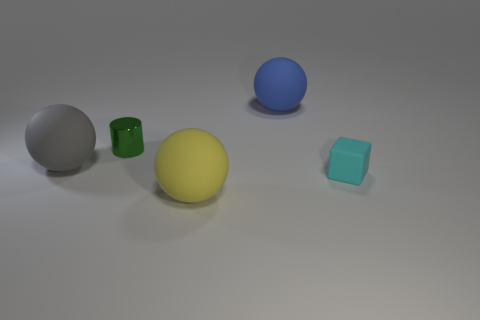Add 1 big yellow matte things. How many objects exist? 6 Subtract all cylinders. How many objects are left? 4 Add 3 big cyan things. How many big cyan things exist? 3 Subtract 0 blue cylinders. How many objects are left? 5 Subtract all large gray matte blocks. Subtract all shiny things. How many objects are left? 4 Add 4 small cylinders. How many small cylinders are left? 5 